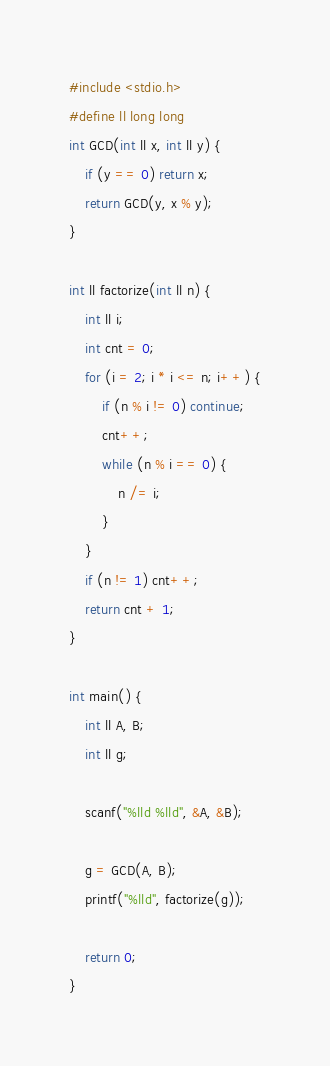<code> <loc_0><loc_0><loc_500><loc_500><_C_>#include <stdio.h>
#define ll long long
int GCD(int ll x, int ll y) {
	if (y == 0) return x;
	return GCD(y, x % y);
}

int ll factorize(int ll n) {
	int ll i;
	int cnt = 0;
	for (i = 2; i * i <= n; i++) {
		if (n % i != 0) continue;
		cnt++;
		while (n % i == 0) {
			n /= i;
		}
	}
	if (n != 1) cnt++;
	return cnt + 1;
}

int main() {
	int ll A, B;
	int ll g;

	scanf("%lld %lld", &A, &B);

	g = GCD(A, B);
	printf("%lld", factorize(g));

	return 0;
}</code> 